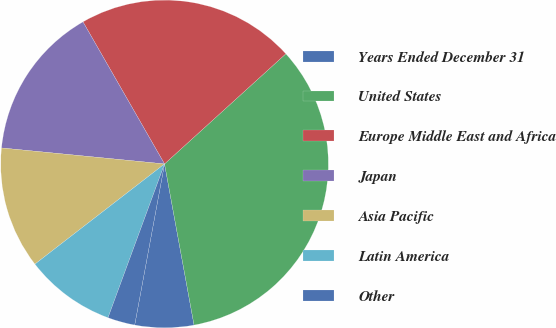Convert chart. <chart><loc_0><loc_0><loc_500><loc_500><pie_chart><fcel>Years Ended December 31<fcel>United States<fcel>Europe Middle East and Africa<fcel>Japan<fcel>Asia Pacific<fcel>Latin America<fcel>Other<nl><fcel>5.8%<fcel>33.85%<fcel>21.56%<fcel>15.15%<fcel>12.03%<fcel>8.92%<fcel>2.69%<nl></chart> 